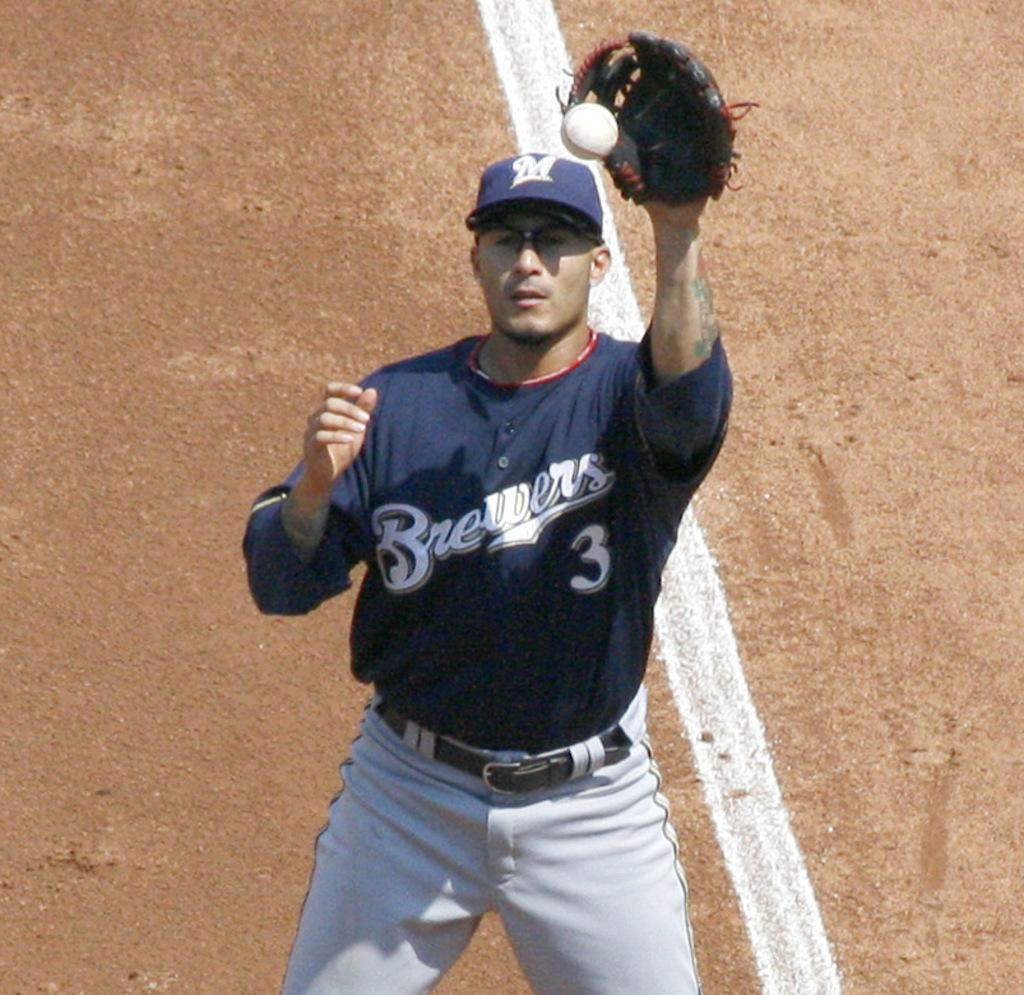<image>
Create a compact narrative representing the image presented. A Brewers baseball player catching a flying ball. 